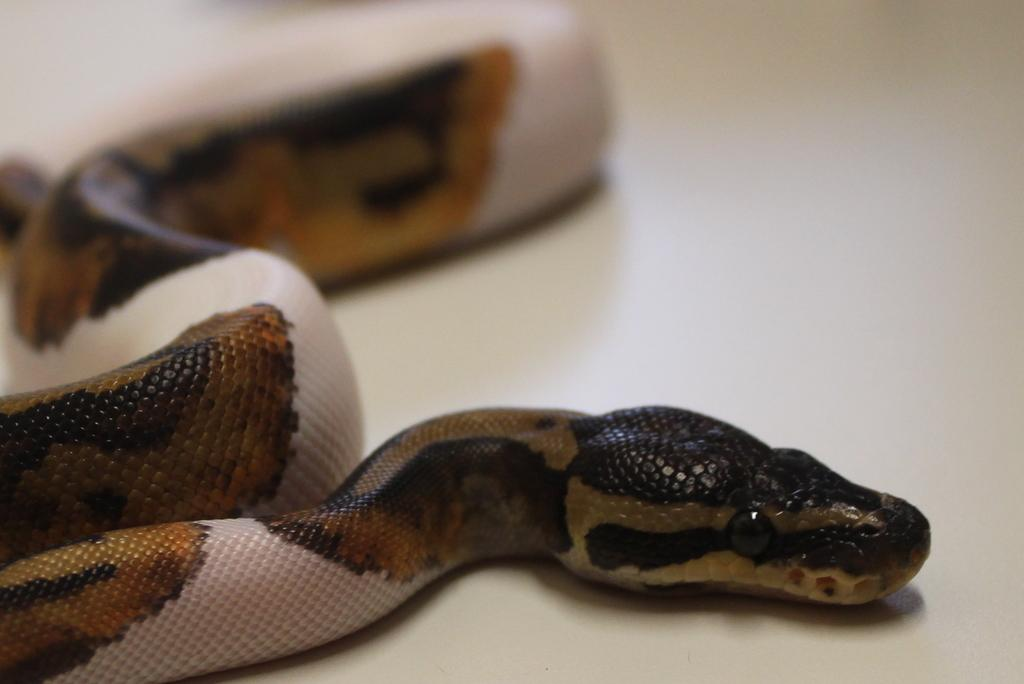What type of animal is present in the image? There is a snake in the image. What type of branch is the snake using to talk to the other animals in the image? There is no branch or other animals present in the image; it only features a snake. 